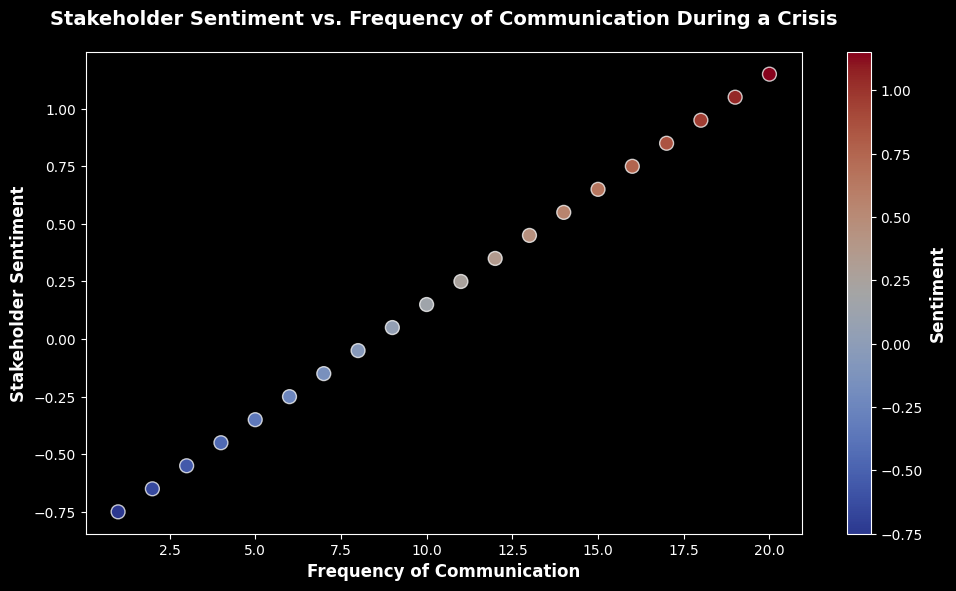What is the relationship between frequency of communication and stakeholder sentiment as shown in the plot? The plot shows a positive correlation between the frequency of corporate communication and stakeholder sentiment during a crisis. As the frequency of communication increases, the sentiment also improves, moving from negative to positive.
Answer: Positive correlation What is the sentiment value when the frequency of communication is 5? To find the sentiment value when the frequency of communication is 5, look at the corresponding point on the x-axis. The sentiment at this point is -0.35.
Answer: -0.35 Which frequency of communication corresponds to a sentiment of 0.75? Locate the sentiment value of 0.75 on the y-axis and find the corresponding frequency of communication on the x-axis. This value is 16.
Answer: 16 How does the sentiment change visually as the frequency of communication increases? The color of the scatter points shifts from blue to red as the frequency increases from 1 to 20, indicating an improvement in sentiment from negative to positive.
Answer: Sentiment improves What is the average sentiment for the frequencies of communication 10, 11, and 12? Identify the sentiment values for frequencies 10, 11, and 12: 0.15, 0.25, and 0.35. Average these values: (0.15 + 0.25 + 0.35) / 3 = 0.25.
Answer: 0.25 Which point, based on color, represents the lowest sentiment value? The point with the lowest sentiment has the darkest blue color. This color corresponds to the frequency of communication at 1, where the sentiment is -0.75.
Answer: Frequency 1 Compare the sentiment values at the frequencies 8 and 18. Which is higher? At frequency 8, the sentiment is -0.05. At frequency 18, the sentiment is 0.95. Since 0.95 is greater than -0.05, the sentiment at frequency 18 is higher.
Answer: Frequency 18 What is the range of sentiment values shown in the figure? The minimum sentiment value is -0.75 (at frequency 1) and the maximum sentiment value is 1.15 (at frequency 20). The range is therefore 1.15 - (-0.75) = 1.9.
Answer: 1.9 Is there any sentiment value corresponding to a neutral sentiment (i.e., 0)? If yes, at what frequency? Check the plot for a sentiment value of 0 on the y-axis. There is no point on the plot where the sentiment is exactly 0.
Answer: No 